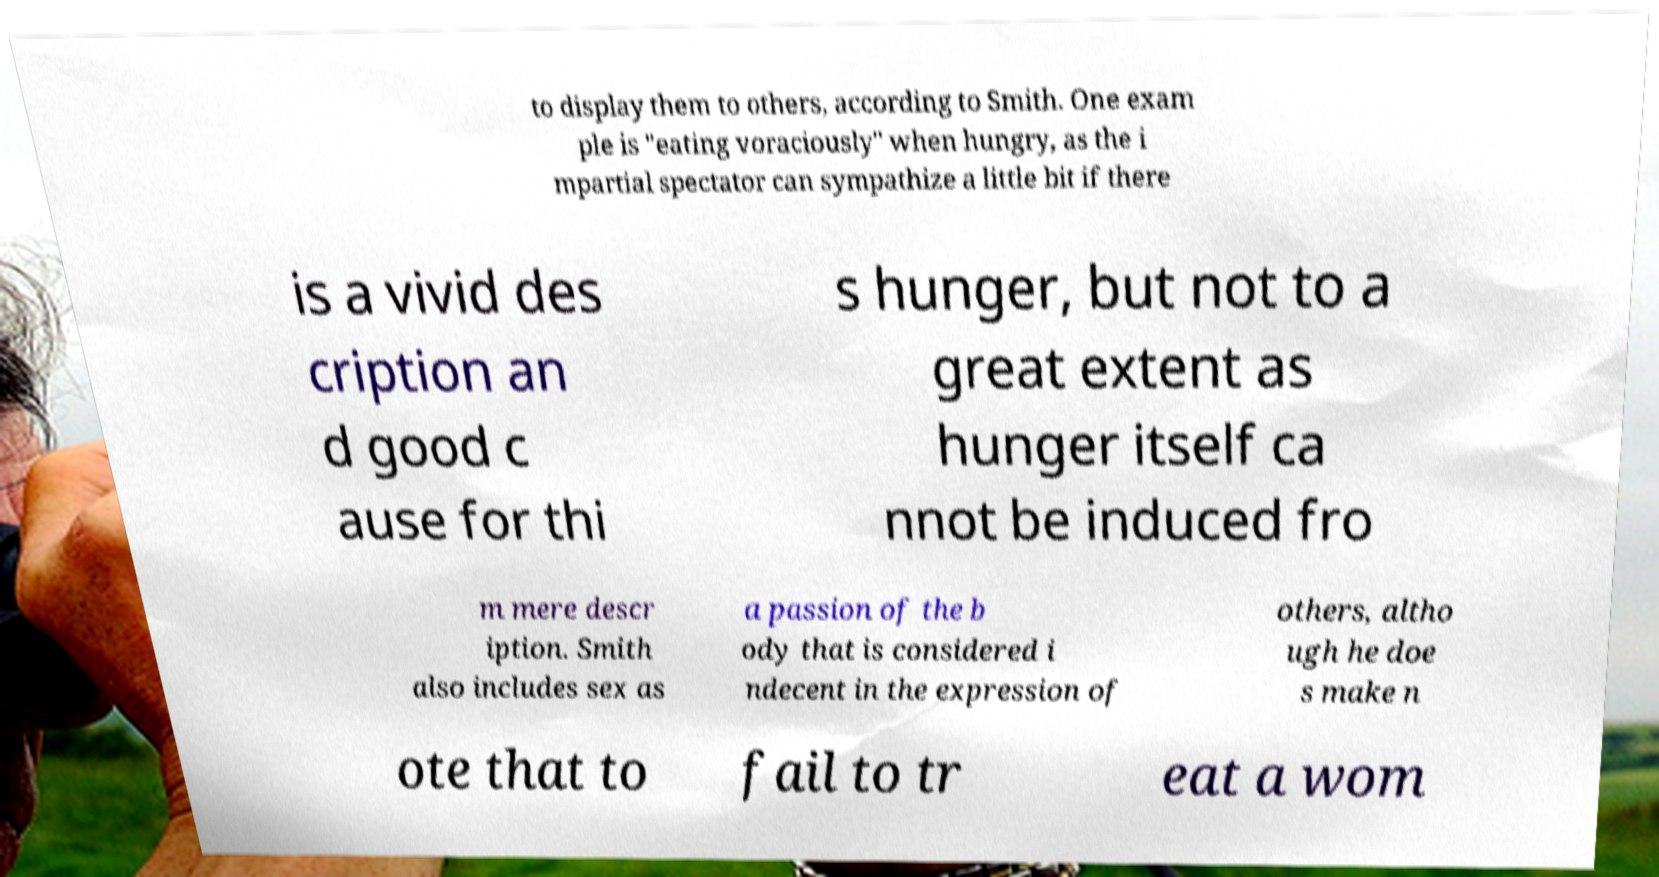Can you accurately transcribe the text from the provided image for me? to display them to others, according to Smith. One exam ple is "eating voraciously" when hungry, as the i mpartial spectator can sympathize a little bit if there is a vivid des cription an d good c ause for thi s hunger, but not to a great extent as hunger itself ca nnot be induced fro m mere descr iption. Smith also includes sex as a passion of the b ody that is considered i ndecent in the expression of others, altho ugh he doe s make n ote that to fail to tr eat a wom 